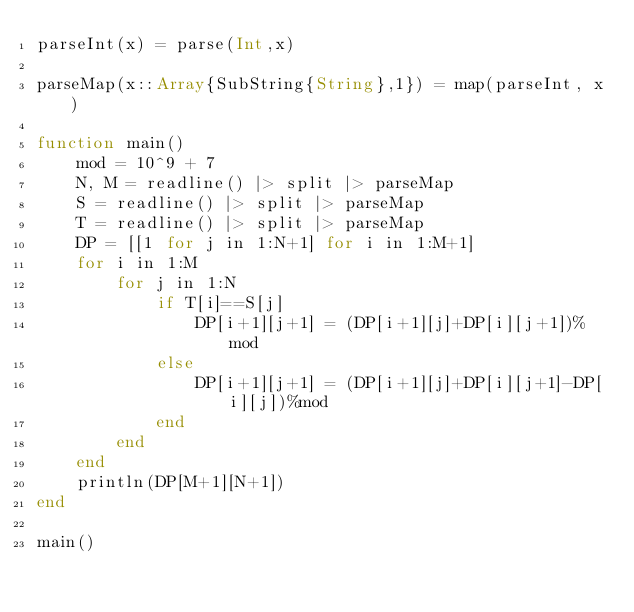<code> <loc_0><loc_0><loc_500><loc_500><_Julia_>parseInt(x) = parse(Int,x)

parseMap(x::Array{SubString{String},1}) = map(parseInt, x)

function main()
    mod = 10^9 + 7
    N, M = readline() |> split |> parseMap
    S = readline() |> split |> parseMap
    T = readline() |> split |> parseMap
    DP = [[1 for j in 1:N+1] for i in 1:M+1]
    for i in 1:M
        for j in 1:N
            if T[i]==S[j]
                DP[i+1][j+1] = (DP[i+1][j]+DP[i][j+1])%mod
            else
                DP[i+1][j+1] = (DP[i+1][j]+DP[i][j+1]-DP[i][j])%mod
            end
        end
    end
    println(DP[M+1][N+1])
end

main()</code> 